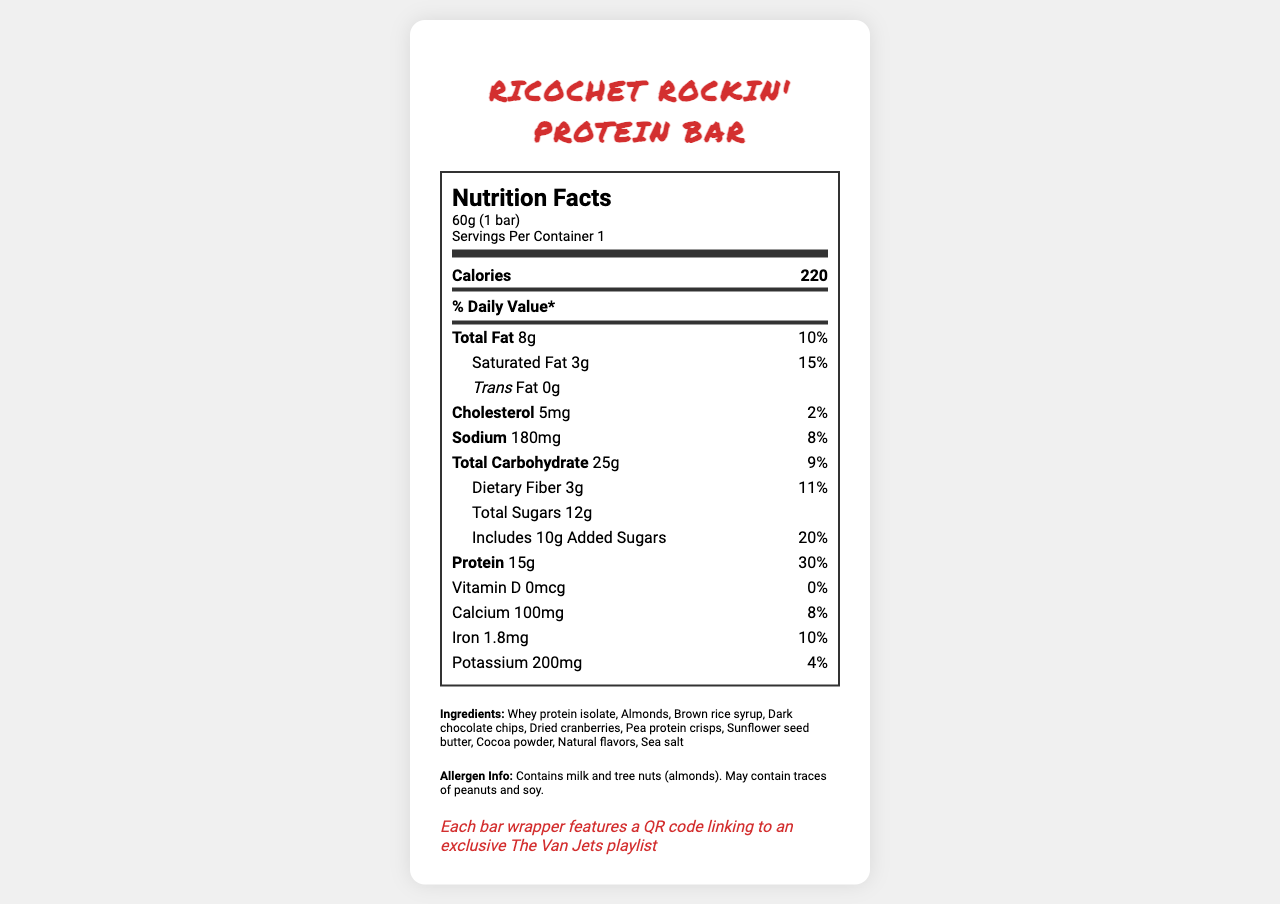when should the protein bar be consumed for the best performance? The label does not provide information on the optimal time to consume the protein bar for performance.
Answer: Not enough information what is the serving size of the Ricochet Rockin' Protein Bar? The serving size is explicitly stated in the document as "60g (1 bar)."
Answer: 60g (1 bar) how many calories are in one serving of the protein bar? The document lists the calorie content as 220.
Answer: 220 what is the total amount of saturated fat per serving, and what percentage of the daily value does it represent? The label shows 3g of saturated fat per serving, representing 15% of the daily value.
Answer: 3g, 15% does the protein bar contain trans fat? The document notes that the protein bar contains 0g of trans fat.
Answer: No is the protein bar suitable for someone with a peanut allergy? The allergen information indicates that the protein bar "may contain traces of peanuts."
Answer: Possibly not safe how much protein does the Ricochet Rockin' Protein Bar provide per serving? Protein content is listed as 15g per serving.
Answer: 15g what are two major allergens in the Ricochet Rockin' Protein Bar? The allergen information states that the bar contains milk and tree nuts (almonds).
Answer: Milk and tree nuts (almonds) how many grams of dietary fiber are in the protein bar? The document lists dietary fiber content as 3g.
Answer: 3g which element from The Van Jets' inspiration is included to support vocal health? According to the inspired elements, antioxidants from cocoa and cranberries are included to support vocal health.
Answer: Antioxidants from cocoa and cranberries which amount of Vitamin D is in the Ricochet Rockin' Protein Bar? The document lists Vitamin D content as 0mcg.
Answer: 0mcg which ingredient is NOT found in the Ricochet Rockin' Protein Bar? A. Whey protein isolate B. Peanuts C. Dark chocolate chips The ingredient list includes whey protein isolate and dark chocolate chips, but not peanuts.
Answer: B. Peanuts how much sodium is in one serving of the protein bar? The document specifies that one serving contains 180mg of sodium.
Answer: 180mg what is the main theme represented by the flavor profile of the Ricochet Rockin' Protein Bar? A. Exotic B. Rock energy C. Sweet and fruity D. Nutty The flavor profile of dark chocolate and cranberry is intended to represent the band's rock energy.
Answer: B. Rock energy what percentage of the daily value does the protein content represent? The protein content represents 30% of the daily value.
Answer: 30% describe the Ricochet Rockin' Protein Bar nutrition label The nutrition label offers comprehensive nutritional details like calories and macronutrients for a single bar serving, lists its key ingredients, and mentions allergen risks. It uniquely ties in elements inspired by The Van Jets, emphasizing steady energy release and incorporating antioxidants to support vocal health, with an exclusive QR code on each wrapper.
Answer: The Ricochet Rockin' Protein Bar nutrition label lists detailed nutritional information for a 60g serving size, including calories, fats, cholesterol, sodium, carbohydrates, fibers, sugars, protein, vitamins, and minerals. It also provides ingredient details and allergen information. Unique elements linked to The Van Jets are highlighted, such as antioxidants for vocal health and a QR code linking to an exclusive playlist. 